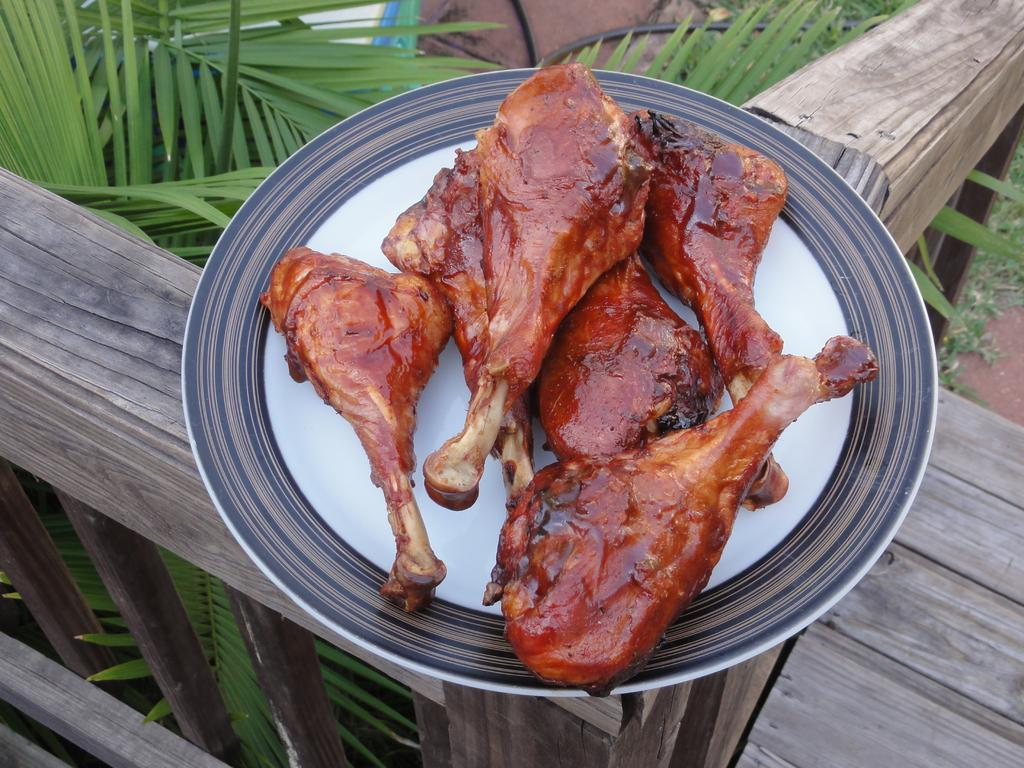What is on the plate that is visible in the image? The plate contains meat. Where is the plate located in the image? The plate is on a wooden fence. What type of vegetation can be seen in the image? There are trees visible in the image. What type of juice is being served in the image? There is no juice present in the image; it features a plate of meat on a wooden fence with trees in the background. 